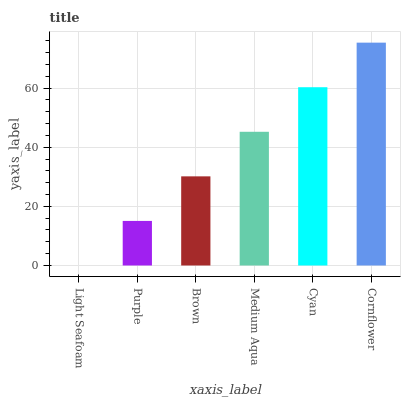Is Purple the minimum?
Answer yes or no. No. Is Purple the maximum?
Answer yes or no. No. Is Purple greater than Light Seafoam?
Answer yes or no. Yes. Is Light Seafoam less than Purple?
Answer yes or no. Yes. Is Light Seafoam greater than Purple?
Answer yes or no. No. Is Purple less than Light Seafoam?
Answer yes or no. No. Is Medium Aqua the high median?
Answer yes or no. Yes. Is Brown the low median?
Answer yes or no. Yes. Is Brown the high median?
Answer yes or no. No. Is Purple the low median?
Answer yes or no. No. 